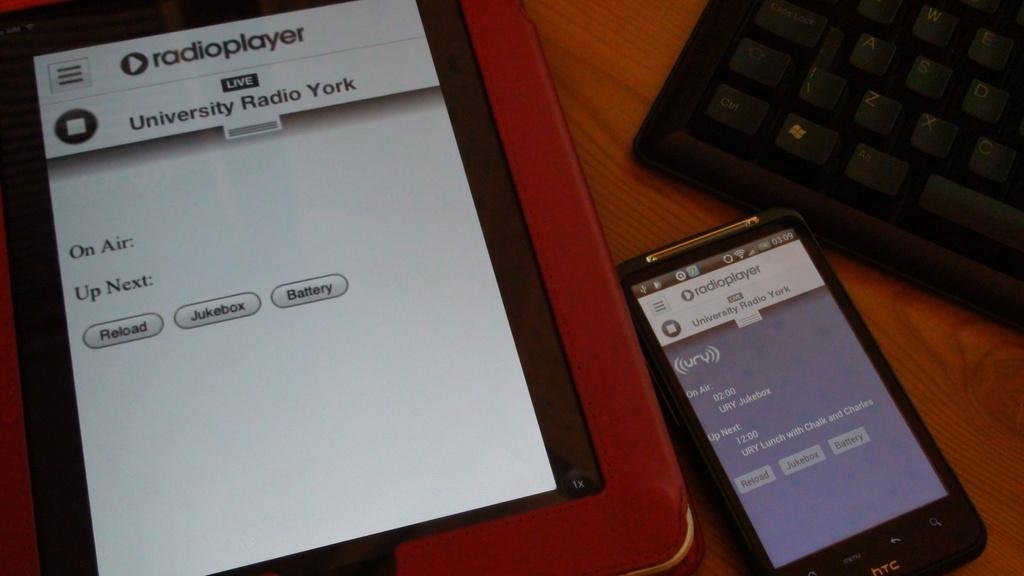<image>
Summarize the visual content of the image. The time under the word on air on the phone 